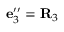Convert formula to latex. <formula><loc_0><loc_0><loc_500><loc_500>{ e } _ { 3 } ^ { \prime \prime } = { R } _ { 3 }</formula> 